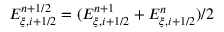<formula> <loc_0><loc_0><loc_500><loc_500>{ E } _ { \xi , i + 1 / 2 } ^ { n + 1 / 2 } = ( { E } _ { \xi , i + 1 / 2 } ^ { n + 1 } + { E } _ { \xi , i + 1 / 2 } ^ { n } ) / 2</formula> 